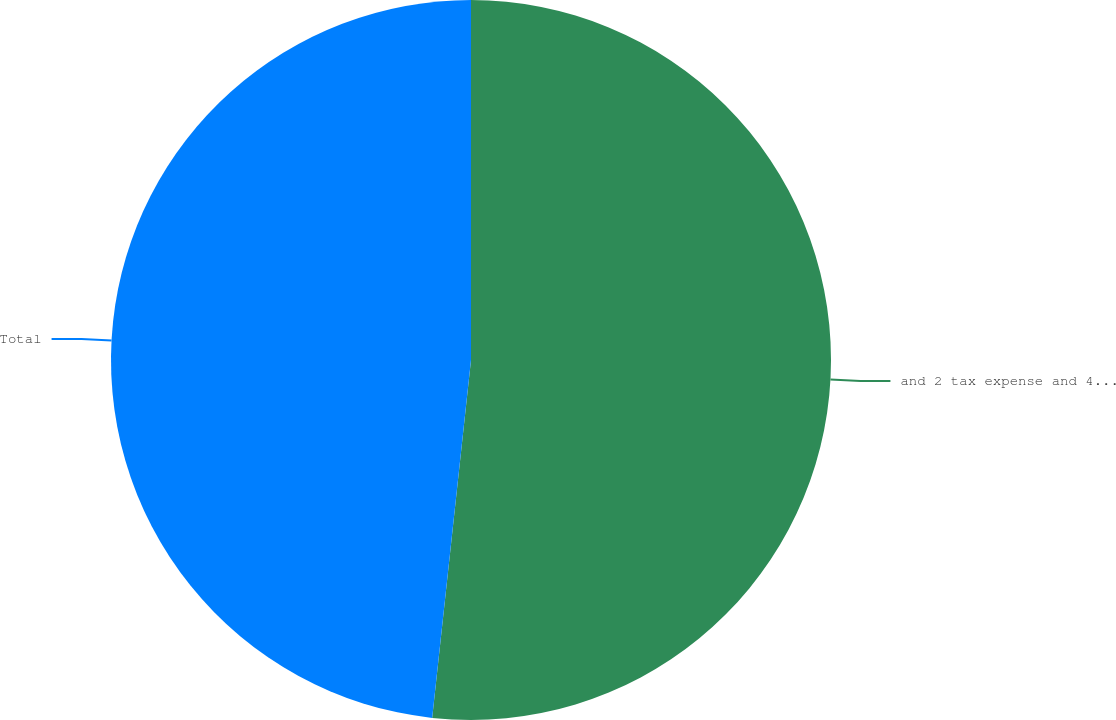Convert chart to OTSL. <chart><loc_0><loc_0><loc_500><loc_500><pie_chart><fcel>and 2 tax expense and 4 tax<fcel>Total<nl><fcel>51.72%<fcel>48.28%<nl></chart> 